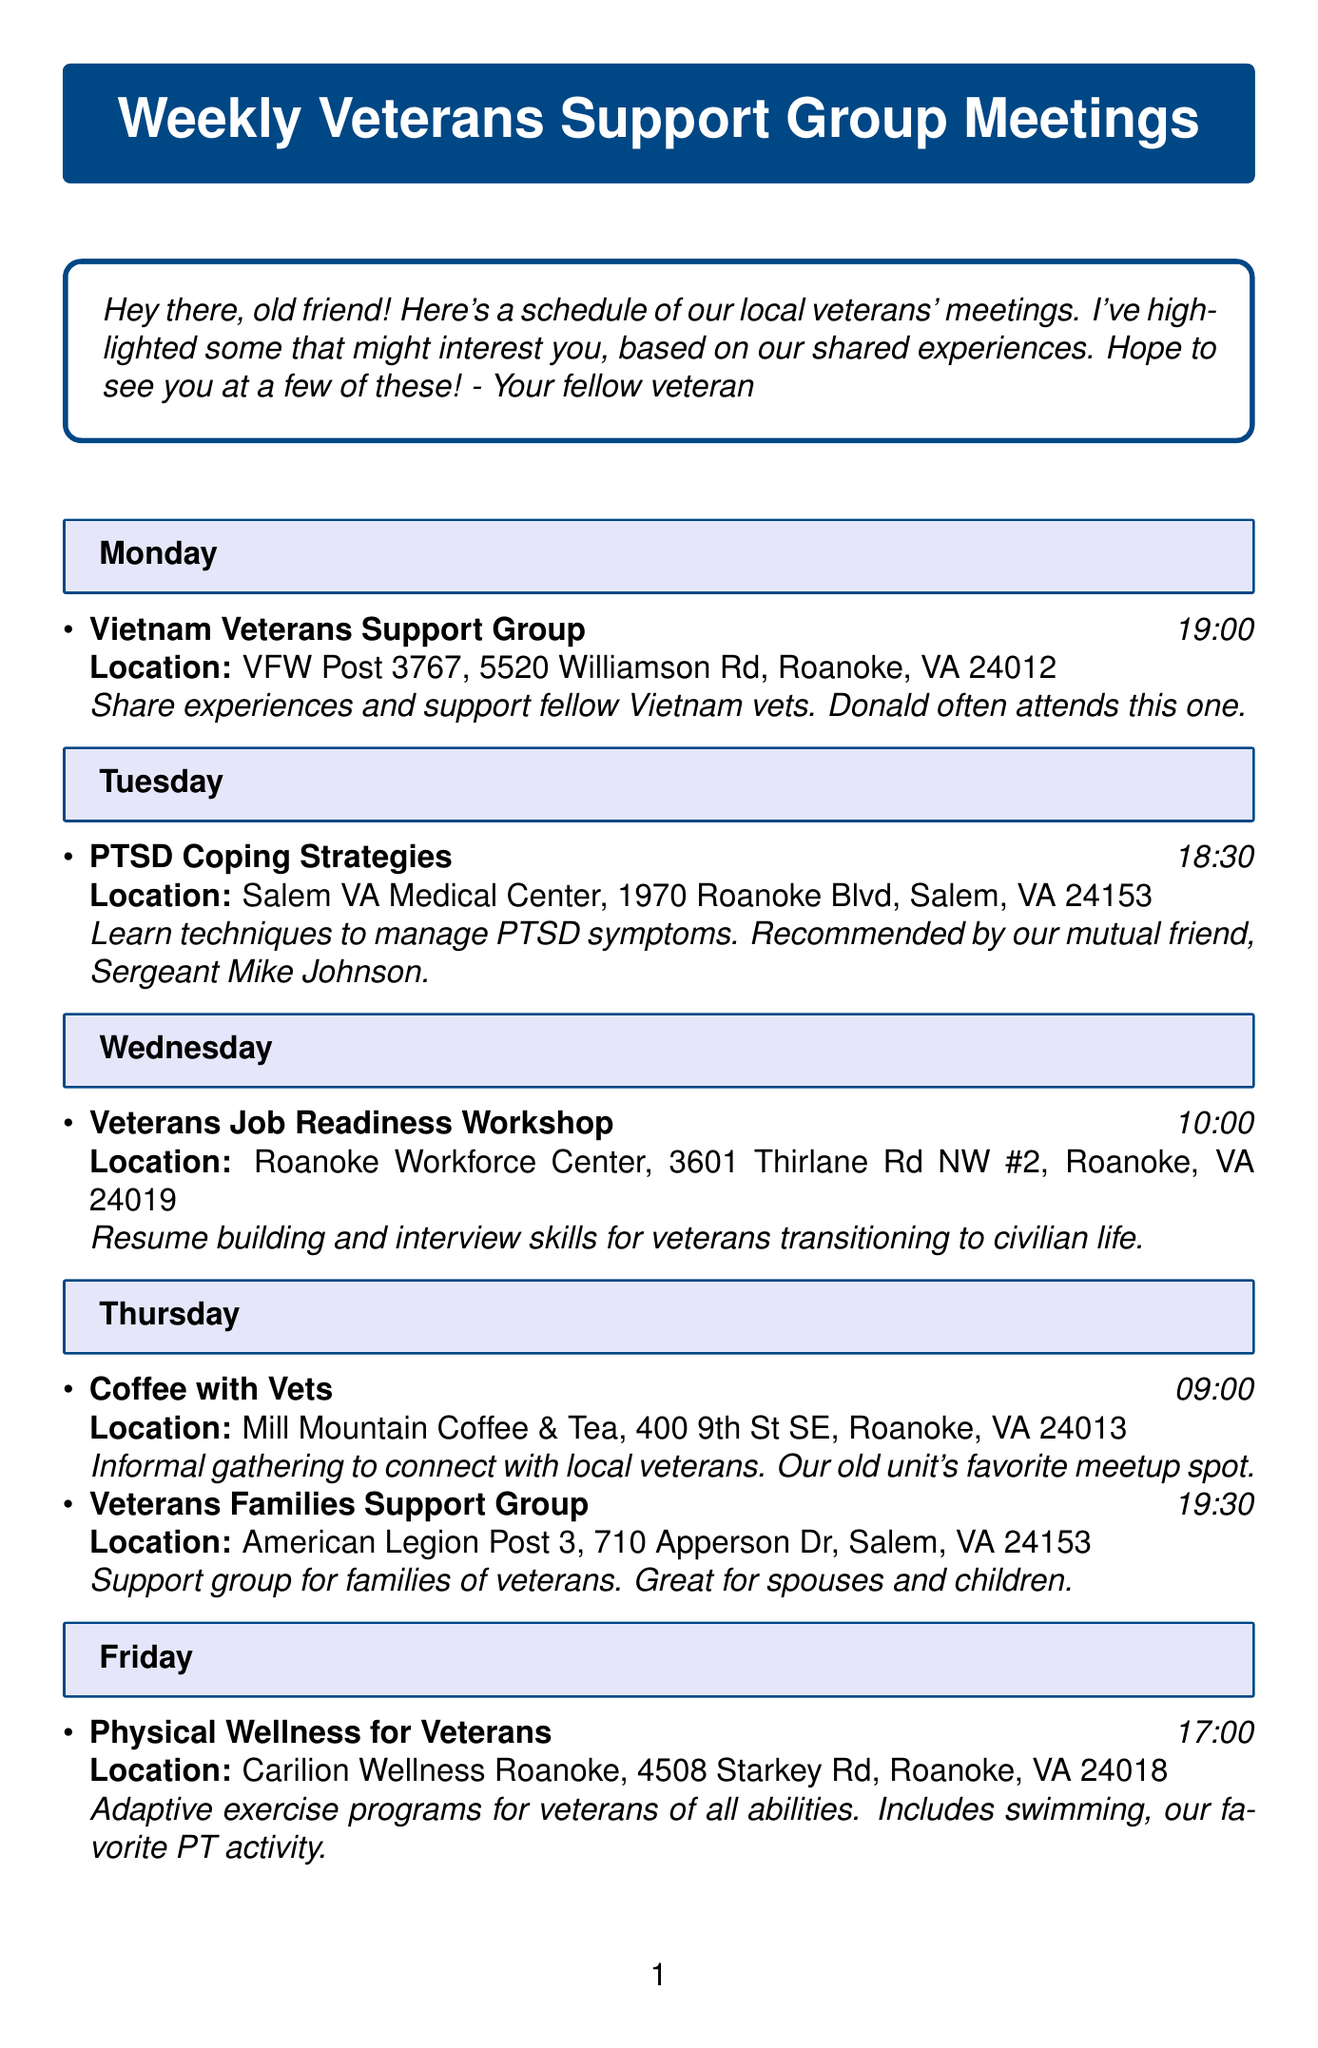what time does the Vietnam Veterans Support Group meet? The schedule indicates that the meeting is at 19:00 on Monday.
Answer: 19:00 where is the PTSD Coping Strategies meeting held? The document states the location as Salem VA Medical Center, 1970 Roanoke Blvd, Salem, VA 24153.
Answer: Salem VA Medical Center, 1970 Roanoke Blvd, Salem, VA 24153 which group meets on Thursday evening? The document lists the Veterans Families Support Group meeting time as 19:30 on Thursday.
Answer: Veterans Families Support Group what is the primary focus of the Veterans Job Readiness Workshop? According to the document, the focus is on resume building and interview skills for veterans transitioning to civilian life.
Answer: Resume building and interview skills how many meetings occur on Thursday? The document lists two meetings scheduled for Thursday.
Answer: Two which group provides support for families of veterans? The document specifies the Veterans Families Support Group as focused on families of veterans.
Answer: Veterans Families Support Group when is the Physical Wellness for Veterans meeting? The document states that it is scheduled for 17:00 on Friday.
Answer: 17:00 what type of activity does the Veterans Art Therapy meeting involve? The document describes it as an opportunity to express oneself through art.
Answer: Art 